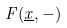Convert formula to latex. <formula><loc_0><loc_0><loc_500><loc_500>F ( \underline { x } , - )</formula> 